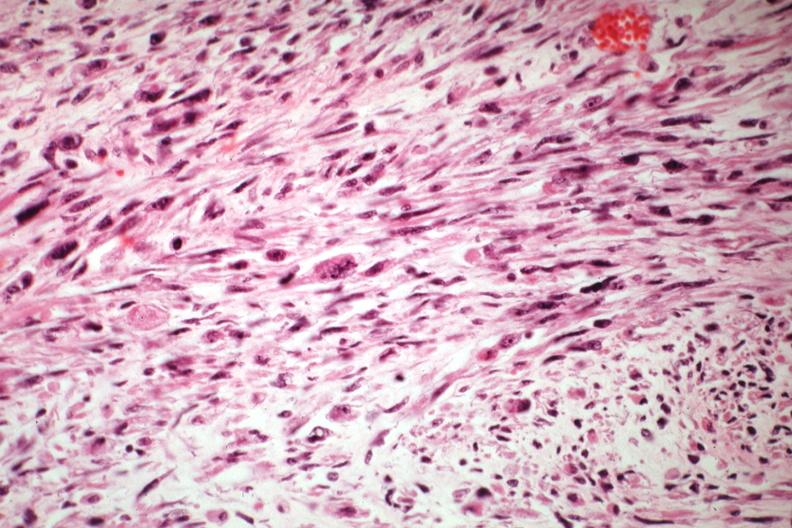what is present?
Answer the question using a single word or phrase. Mixed mesodermal tumor 